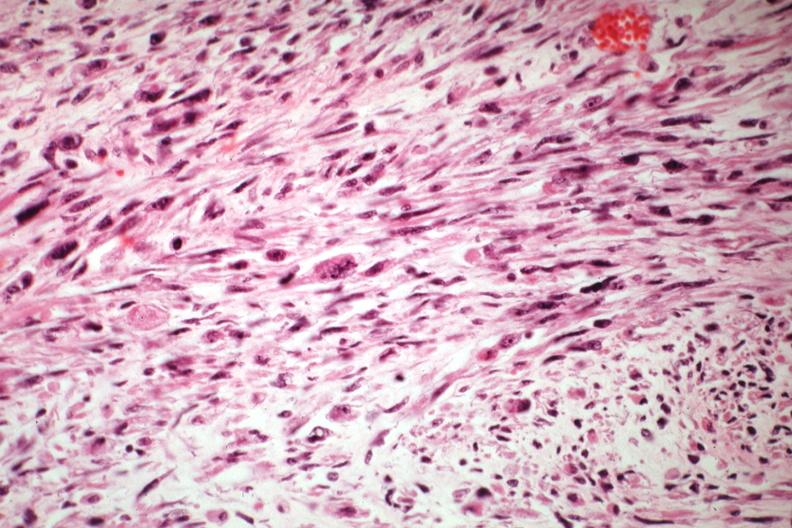what is present?
Answer the question using a single word or phrase. Mixed mesodermal tumor 